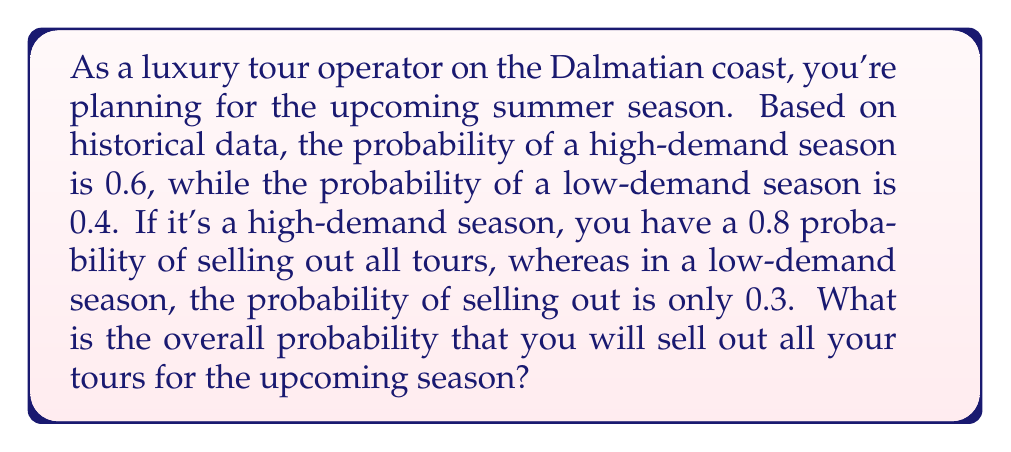What is the answer to this math problem? To solve this problem, we'll use the law of total probability. Let's break it down step by step:

1) Let's define our events:
   A: Sell out all tours
   H: High-demand season
   L: Low-demand season

2) We're given the following probabilities:
   $P(H) = 0.6$ (Probability of a high-demand season)
   $P(L) = 0.4$ (Probability of a low-demand season)
   $P(A|H) = 0.8$ (Probability of selling out given a high-demand season)
   $P(A|L) = 0.3$ (Probability of selling out given a low-demand season)

3) The law of total probability states:
   $P(A) = P(A|H) \cdot P(H) + P(A|L) \cdot P(L)$

4) Let's substitute our values:
   $P(A) = 0.8 \cdot 0.6 + 0.3 \cdot 0.4$

5) Now let's calculate:
   $P(A) = 0.48 + 0.12 = 0.60$

Therefore, the overall probability of selling out all tours for the upcoming season is 0.60 or 60%.
Answer: 0.60 or 60% 